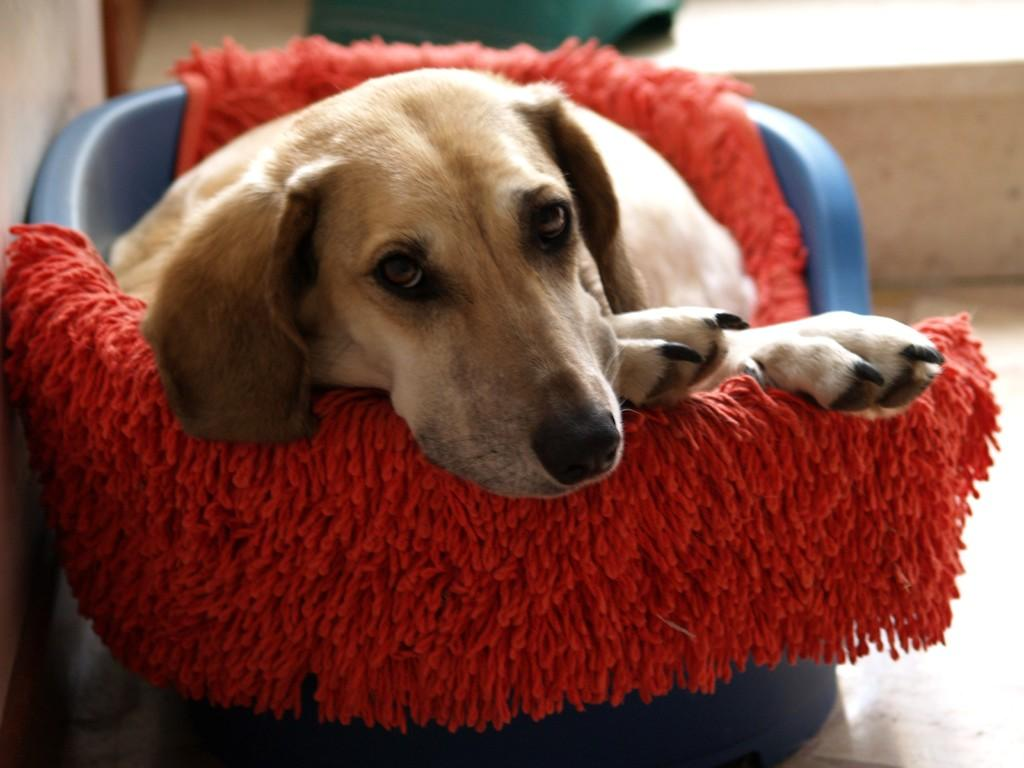What animal can be seen in the image? There is a dog in the image. What is the dog lying on? The dog is lying on a mat. Where is the mat located? The mat is in a tub. What is visible behind the tub? There is an object behind the tub. What part of the room can be seen at the bottom of the image? The floor is visible at the bottom of the image. What type of berry is the dog eating in the image? There is no berry present in the image, and the dog is not eating anything. 